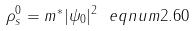Convert formula to latex. <formula><loc_0><loc_0><loc_500><loc_500>\rho _ { s } ^ { 0 } = m ^ { * } | \psi _ { 0 } | ^ { 2 } \ e q n u m { 2 . 6 0 }</formula> 